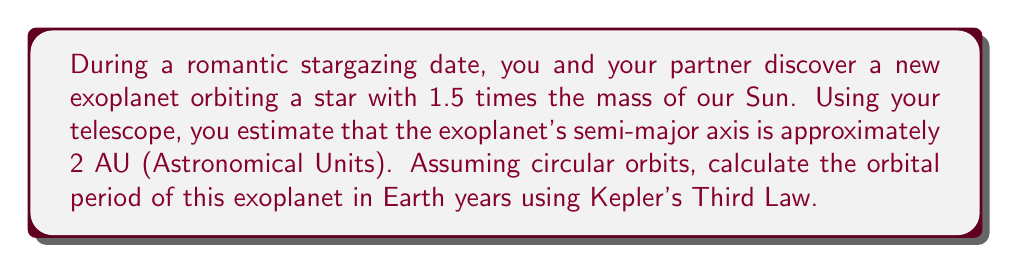Teach me how to tackle this problem. To solve this problem, we'll use Kepler's Third Law, which relates the orbital period of a planet to its semi-major axis and the mass of the central star. The law states that:

$$\frac{T^2}{a^3} = \frac{4\pi^2}{GM}$$

Where:
- $T$ is the orbital period
- $a$ is the semi-major axis
- $G$ is the gravitational constant
- $M$ is the mass of the central star

For our solar system, we can simplify this equation to:

$$T^2 = a^3$$

Where $T$ is in Earth years and $a$ is in Astronomical Units (AU).

For the exoplanet system:
1. The star's mass is 1.5 times the Sun's mass.
2. The exoplanet's semi-major axis is 2 AU.

We need to adjust the equation to account for the different star mass:

$$T^2 = \frac{a^3}{M_{\text{star}}/M_{\text{Sun}}}$$

Plugging in the values:

$$T^2 = \frac{2^3}{1.5} = \frac{8}{1.5} = \frac{16}{3}$$

Taking the square root of both sides:

$$T = \sqrt{\frac{16}{3}} \approx 2.31 \text{ Earth years}$$
Answer: The orbital period of the exoplanet is approximately 2.31 Earth years. 